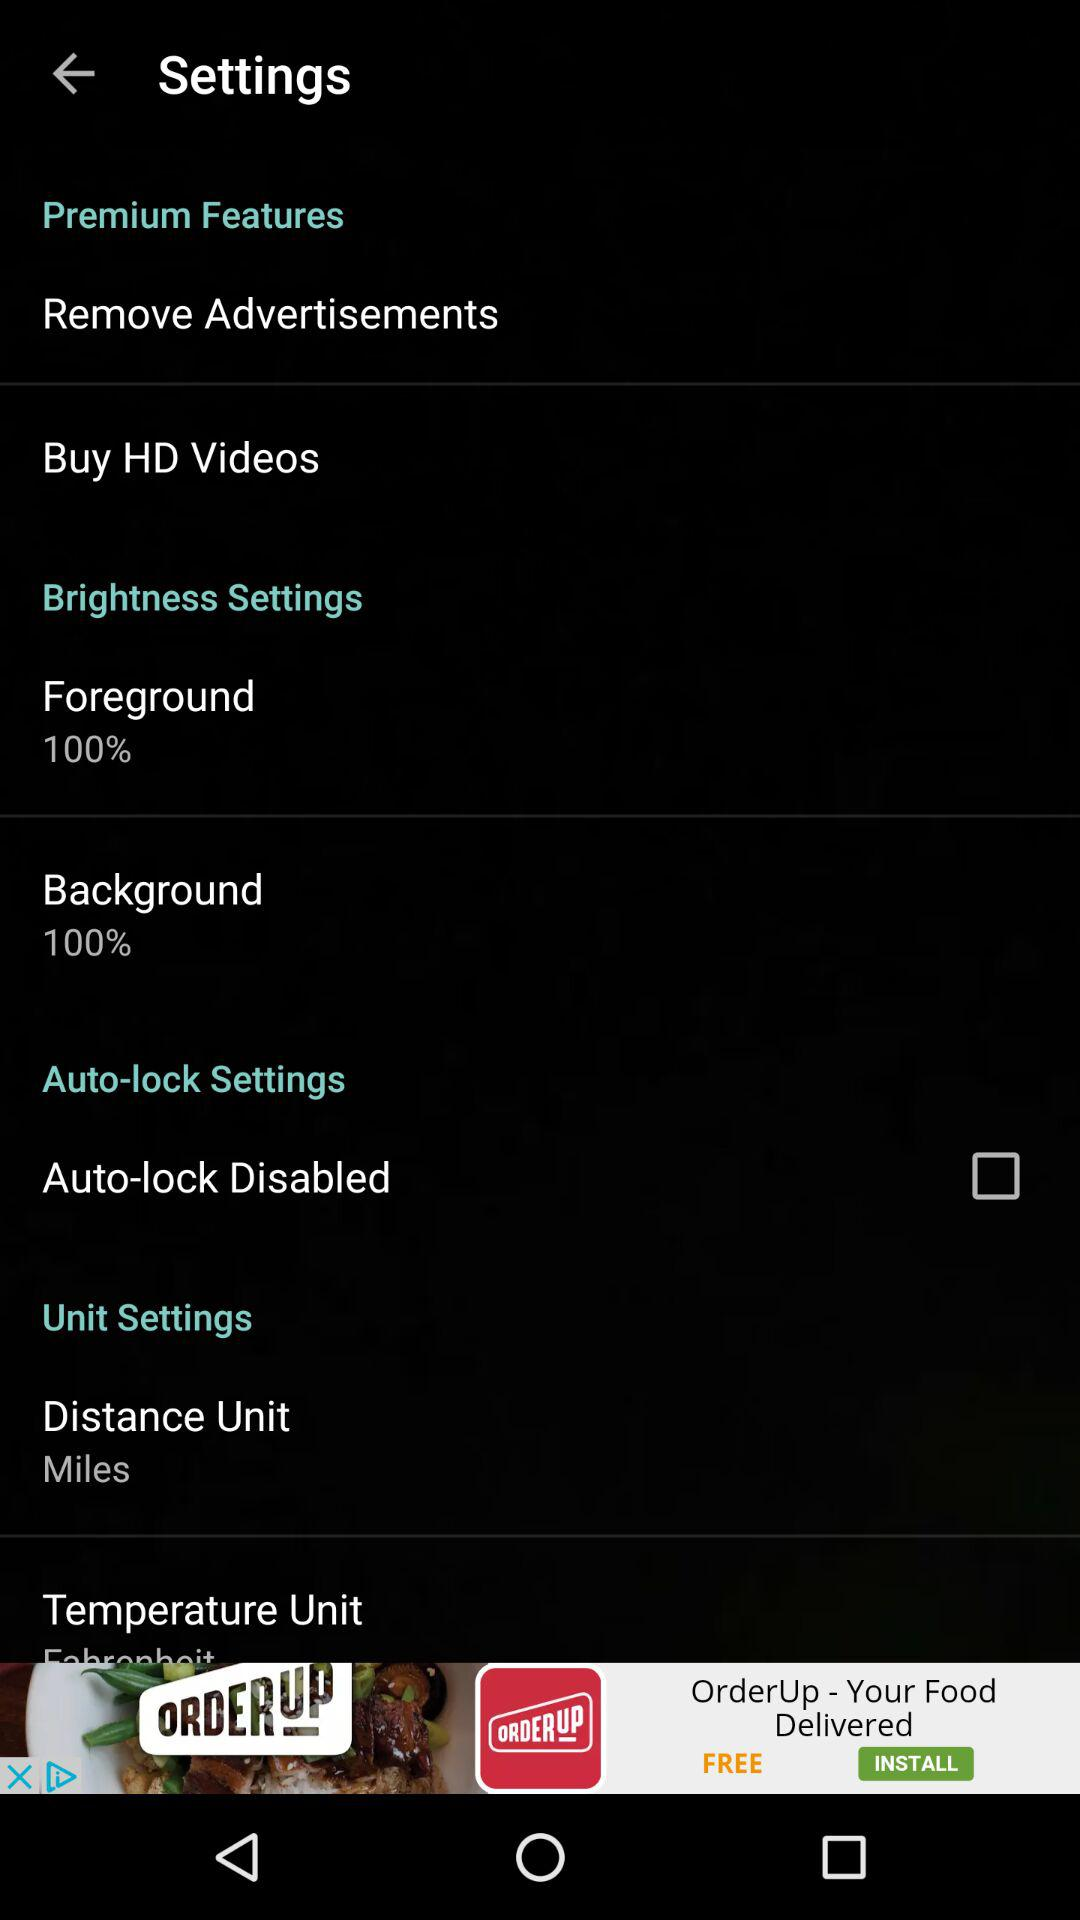What is the brightness percentage of the foreground? The brightness percentage of the foreground is 100. 